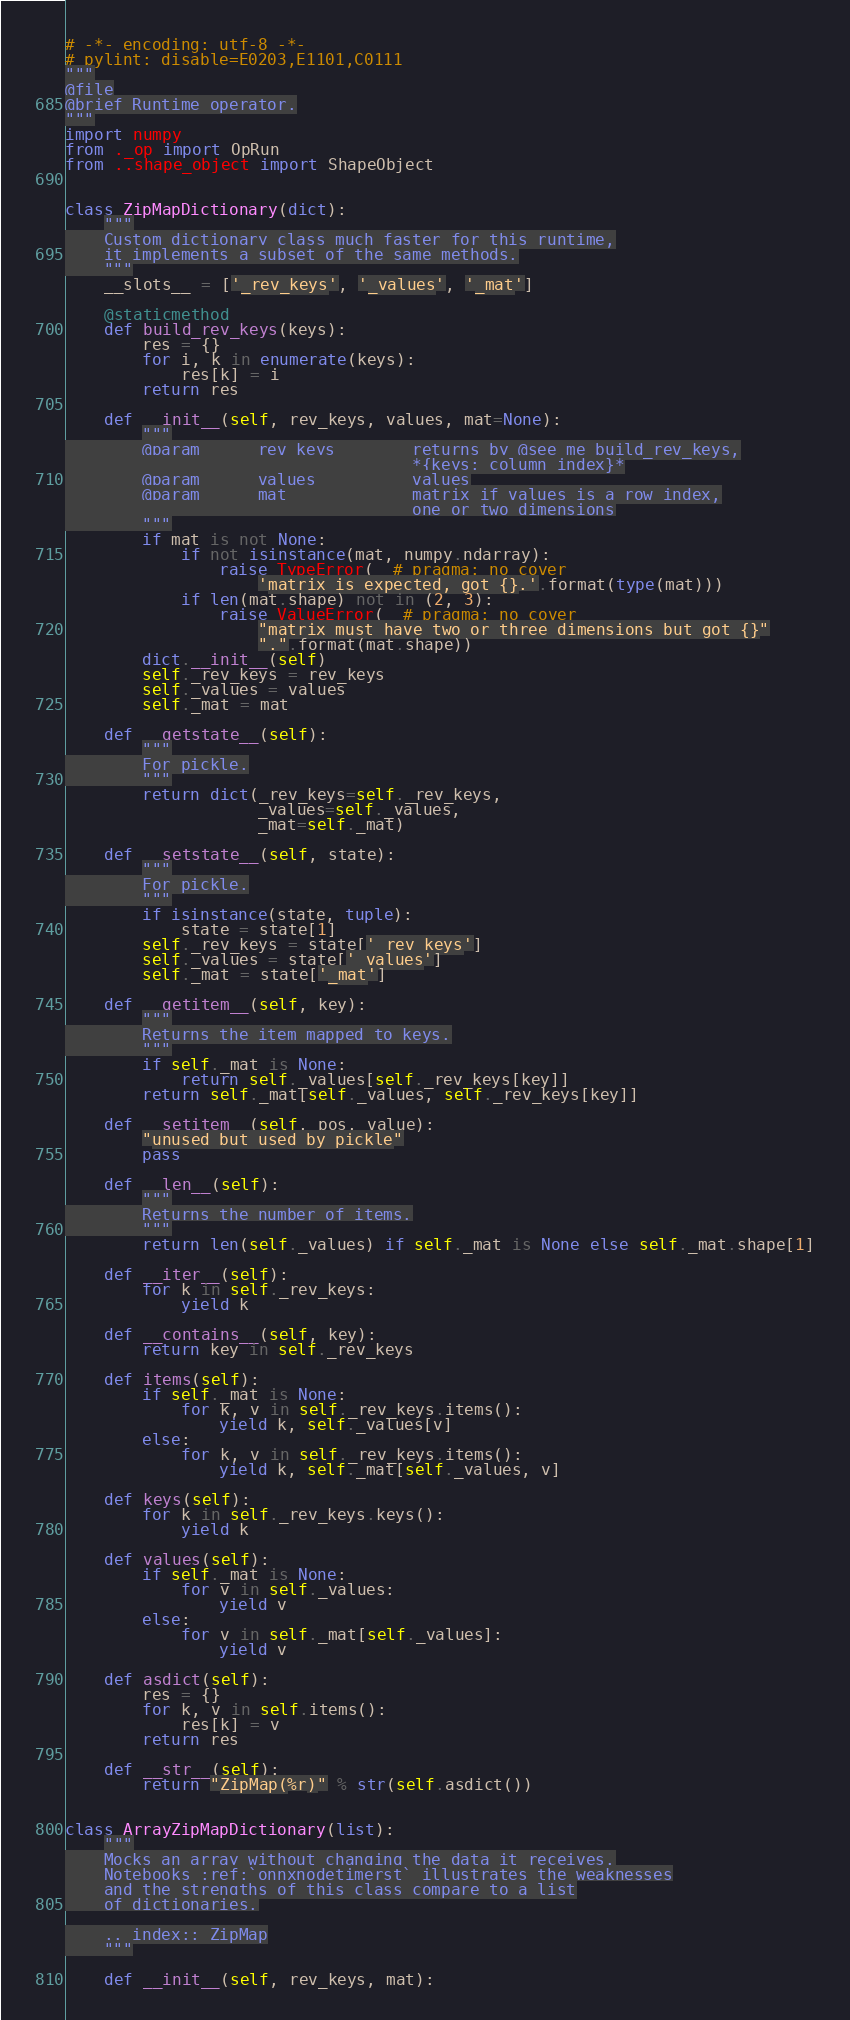<code> <loc_0><loc_0><loc_500><loc_500><_Python_># -*- encoding: utf-8 -*-
# pylint: disable=E0203,E1101,C0111
"""
@file
@brief Runtime operator.
"""
import numpy
from ._op import OpRun
from ..shape_object import ShapeObject


class ZipMapDictionary(dict):
    """
    Custom dictionary class much faster for this runtime,
    it implements a subset of the same methods.
    """
    __slots__ = ['_rev_keys', '_values', '_mat']

    @staticmethod
    def build_rev_keys(keys):
        res = {}
        for i, k in enumerate(keys):
            res[k] = i
        return res

    def __init__(self, rev_keys, values, mat=None):
        """
        @param      rev_keys        returns by @see me build_rev_keys,
                                    *{keys: column index}*
        @param      values          values
        @param      mat             matrix if values is a row index,
                                    one or two dimensions
        """
        if mat is not None:
            if not isinstance(mat, numpy.ndarray):
                raise TypeError(  # pragma: no cover
                    'matrix is expected, got {}.'.format(type(mat)))
            if len(mat.shape) not in (2, 3):
                raise ValueError(  # pragma: no cover
                    "matrix must have two or three dimensions but got {}"
                    ".".format(mat.shape))
        dict.__init__(self)
        self._rev_keys = rev_keys
        self._values = values
        self._mat = mat

    def __getstate__(self):
        """
        For pickle.
        """
        return dict(_rev_keys=self._rev_keys,
                    _values=self._values,
                    _mat=self._mat)

    def __setstate__(self, state):
        """
        For pickle.
        """
        if isinstance(state, tuple):
            state = state[1]
        self._rev_keys = state['_rev_keys']
        self._values = state['_values']
        self._mat = state['_mat']

    def __getitem__(self, key):
        """
        Returns the item mapped to keys.
        """
        if self._mat is None:
            return self._values[self._rev_keys[key]]
        return self._mat[self._values, self._rev_keys[key]]

    def __setitem__(self, pos, value):
        "unused but used by pickle"
        pass

    def __len__(self):
        """
        Returns the number of items.
        """
        return len(self._values) if self._mat is None else self._mat.shape[1]

    def __iter__(self):
        for k in self._rev_keys:
            yield k

    def __contains__(self, key):
        return key in self._rev_keys

    def items(self):
        if self._mat is None:
            for k, v in self._rev_keys.items():
                yield k, self._values[v]
        else:
            for k, v in self._rev_keys.items():
                yield k, self._mat[self._values, v]

    def keys(self):
        for k in self._rev_keys.keys():
            yield k

    def values(self):
        if self._mat is None:
            for v in self._values:
                yield v
        else:
            for v in self._mat[self._values]:
                yield v

    def asdict(self):
        res = {}
        for k, v in self.items():
            res[k] = v
        return res

    def __str__(self):
        return "ZipMap(%r)" % str(self.asdict())


class ArrayZipMapDictionary(list):
    """
    Mocks an array without changing the data it receives.
    Notebooks :ref:`onnxnodetimerst` illustrates the weaknesses
    and the strengths of this class compare to a list
    of dictionaries.

    .. index:: ZipMap
    """

    def __init__(self, rev_keys, mat):</code> 